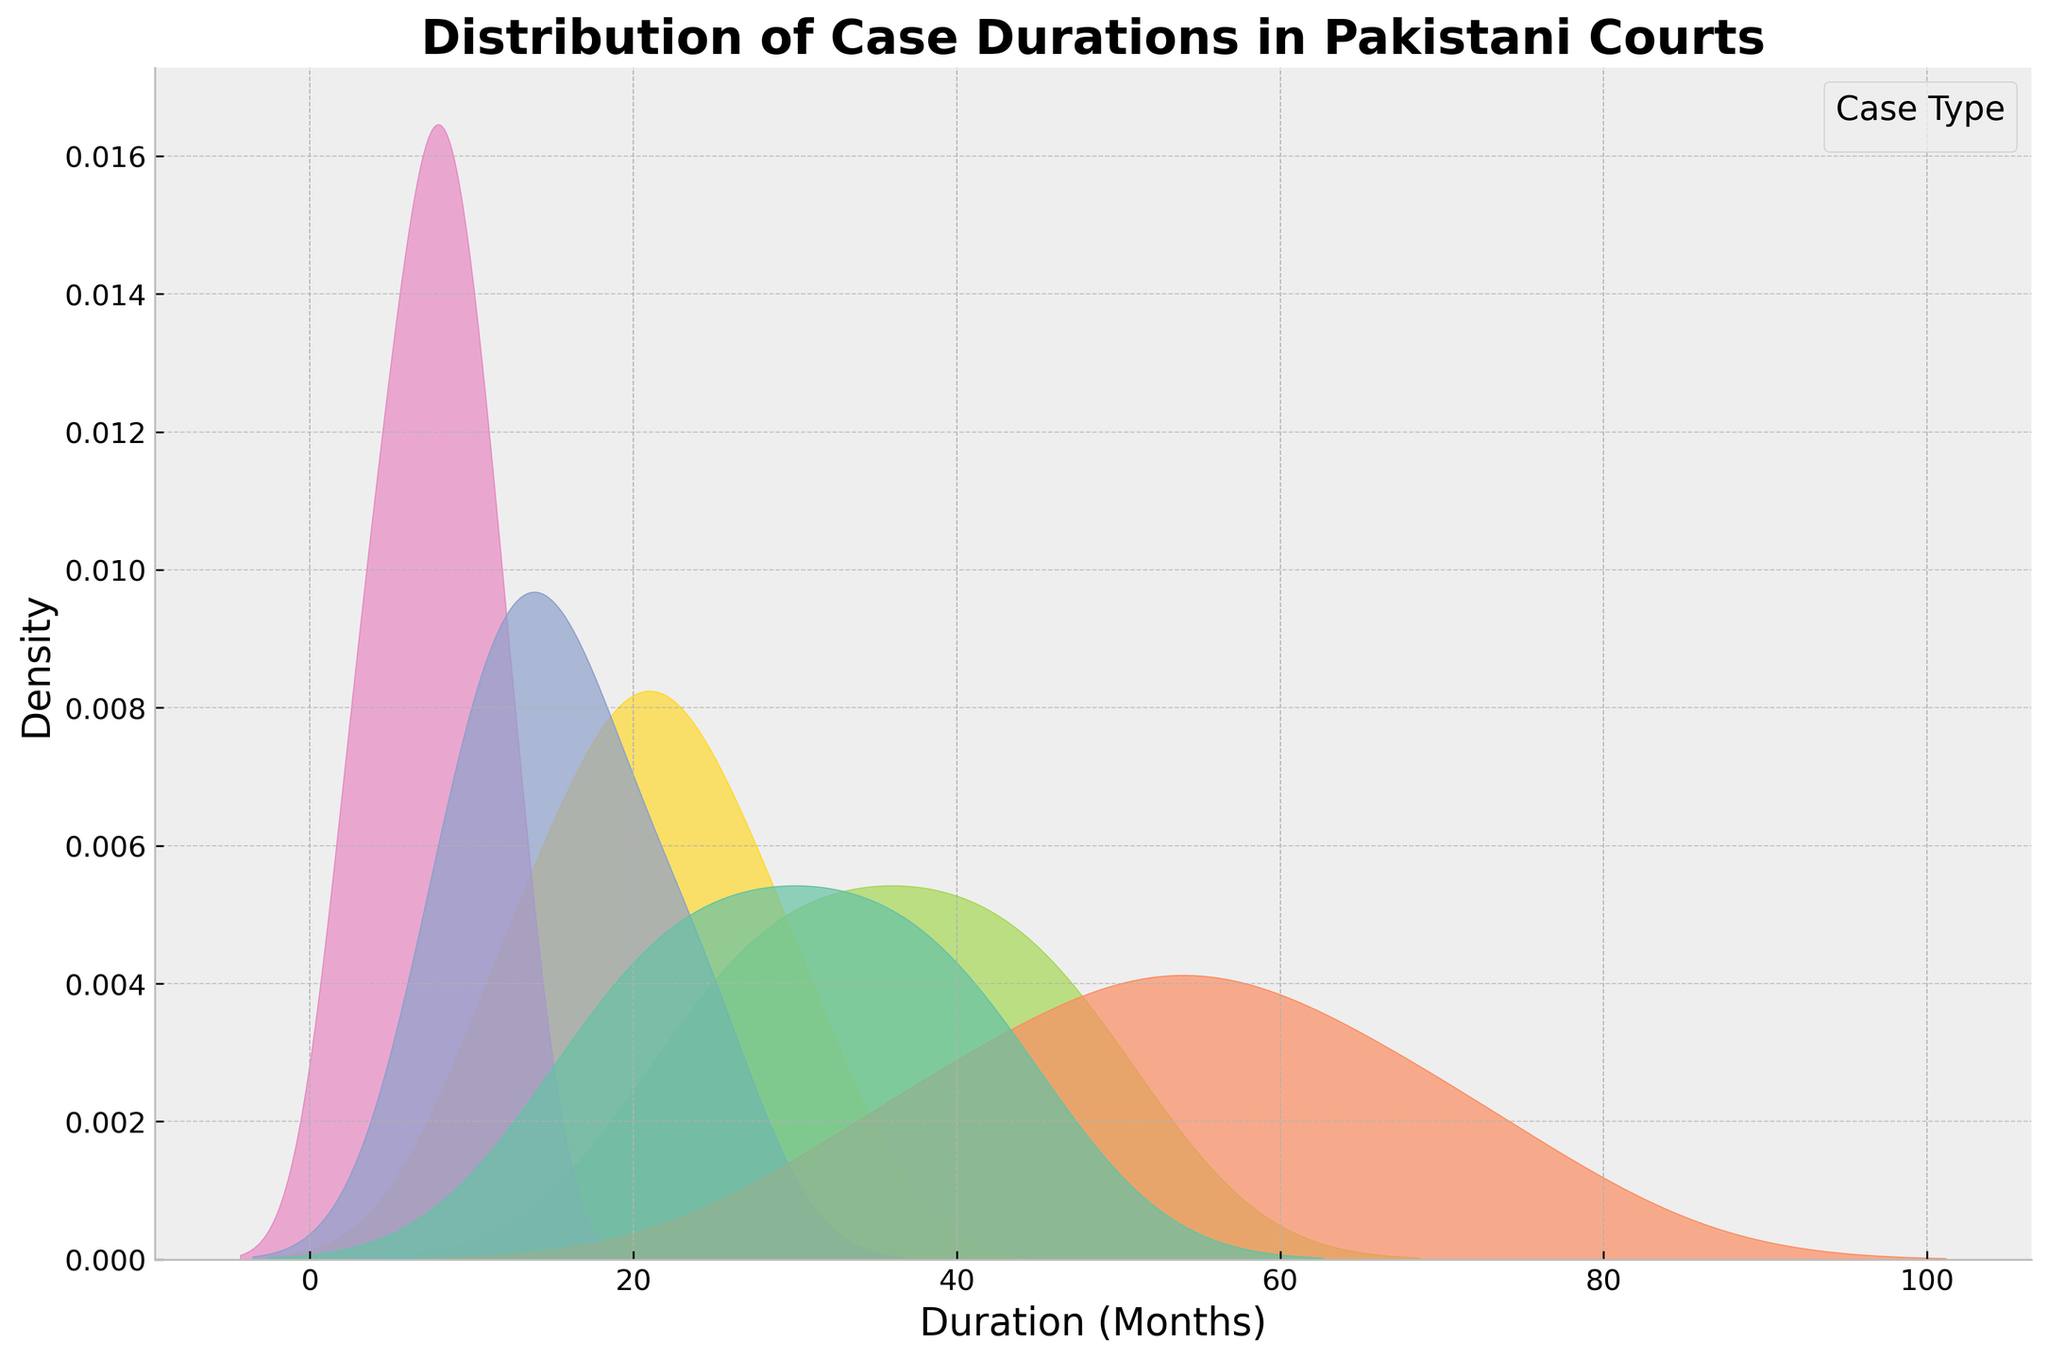What is the title of the plot? The title is indicated at the top of the plot, it summarizes the content of the figure.
Answer: Distribution of Case Durations in Pakistani Courts What does the x-axis represent? The label on the x-axis provides information about what is being measured horizontally.
Answer: Duration (Months) Which case type has its peak density at the shortest duration? Look for the highest peak among the curves representing each case type and see which one appears at the shortest duration on the x-axis.
Answer: Constitutional Which case type has the longest duration peak? Identify the highest peak among all curves and locate the one that appears at the longest duration on the x-axis.
Answer: Civil Which case types have overlapping duration peaks? Observe the kde plot to see which case types' density peaks occur at similar x-axis positions.
Answer: Criminal and Corporate Which case type shows the most spread-out duration distribution? Look for the curve with the widest spread across the x-axis, indicating a wide range of duration months.
Answer: Civil What is the approximate peak duration for Family cases? Find the peak of the Family case density curve and note the corresponding value on the x-axis.
Answer: 15 months How do the durations of Tax cases compare to Constitutional cases? Compare the general spread and peak positions of the density curves for Tax and Constitutional cases.
Answer: Tax cases have longer durations compared to Constitutional cases Which case types have similar density shapes but different peaks? Identify density curves that have a similar overall shape yet peak at different points on the x-axis.
Answer: Criminal and Corporate What is the general trend of case durations for Corporate cases? Observe the kde plot for the Corporate cases and describe the spread and peak of the density curve.
Answer: Peaks at mid durations (around 30-42 months) and is moderately spread out 